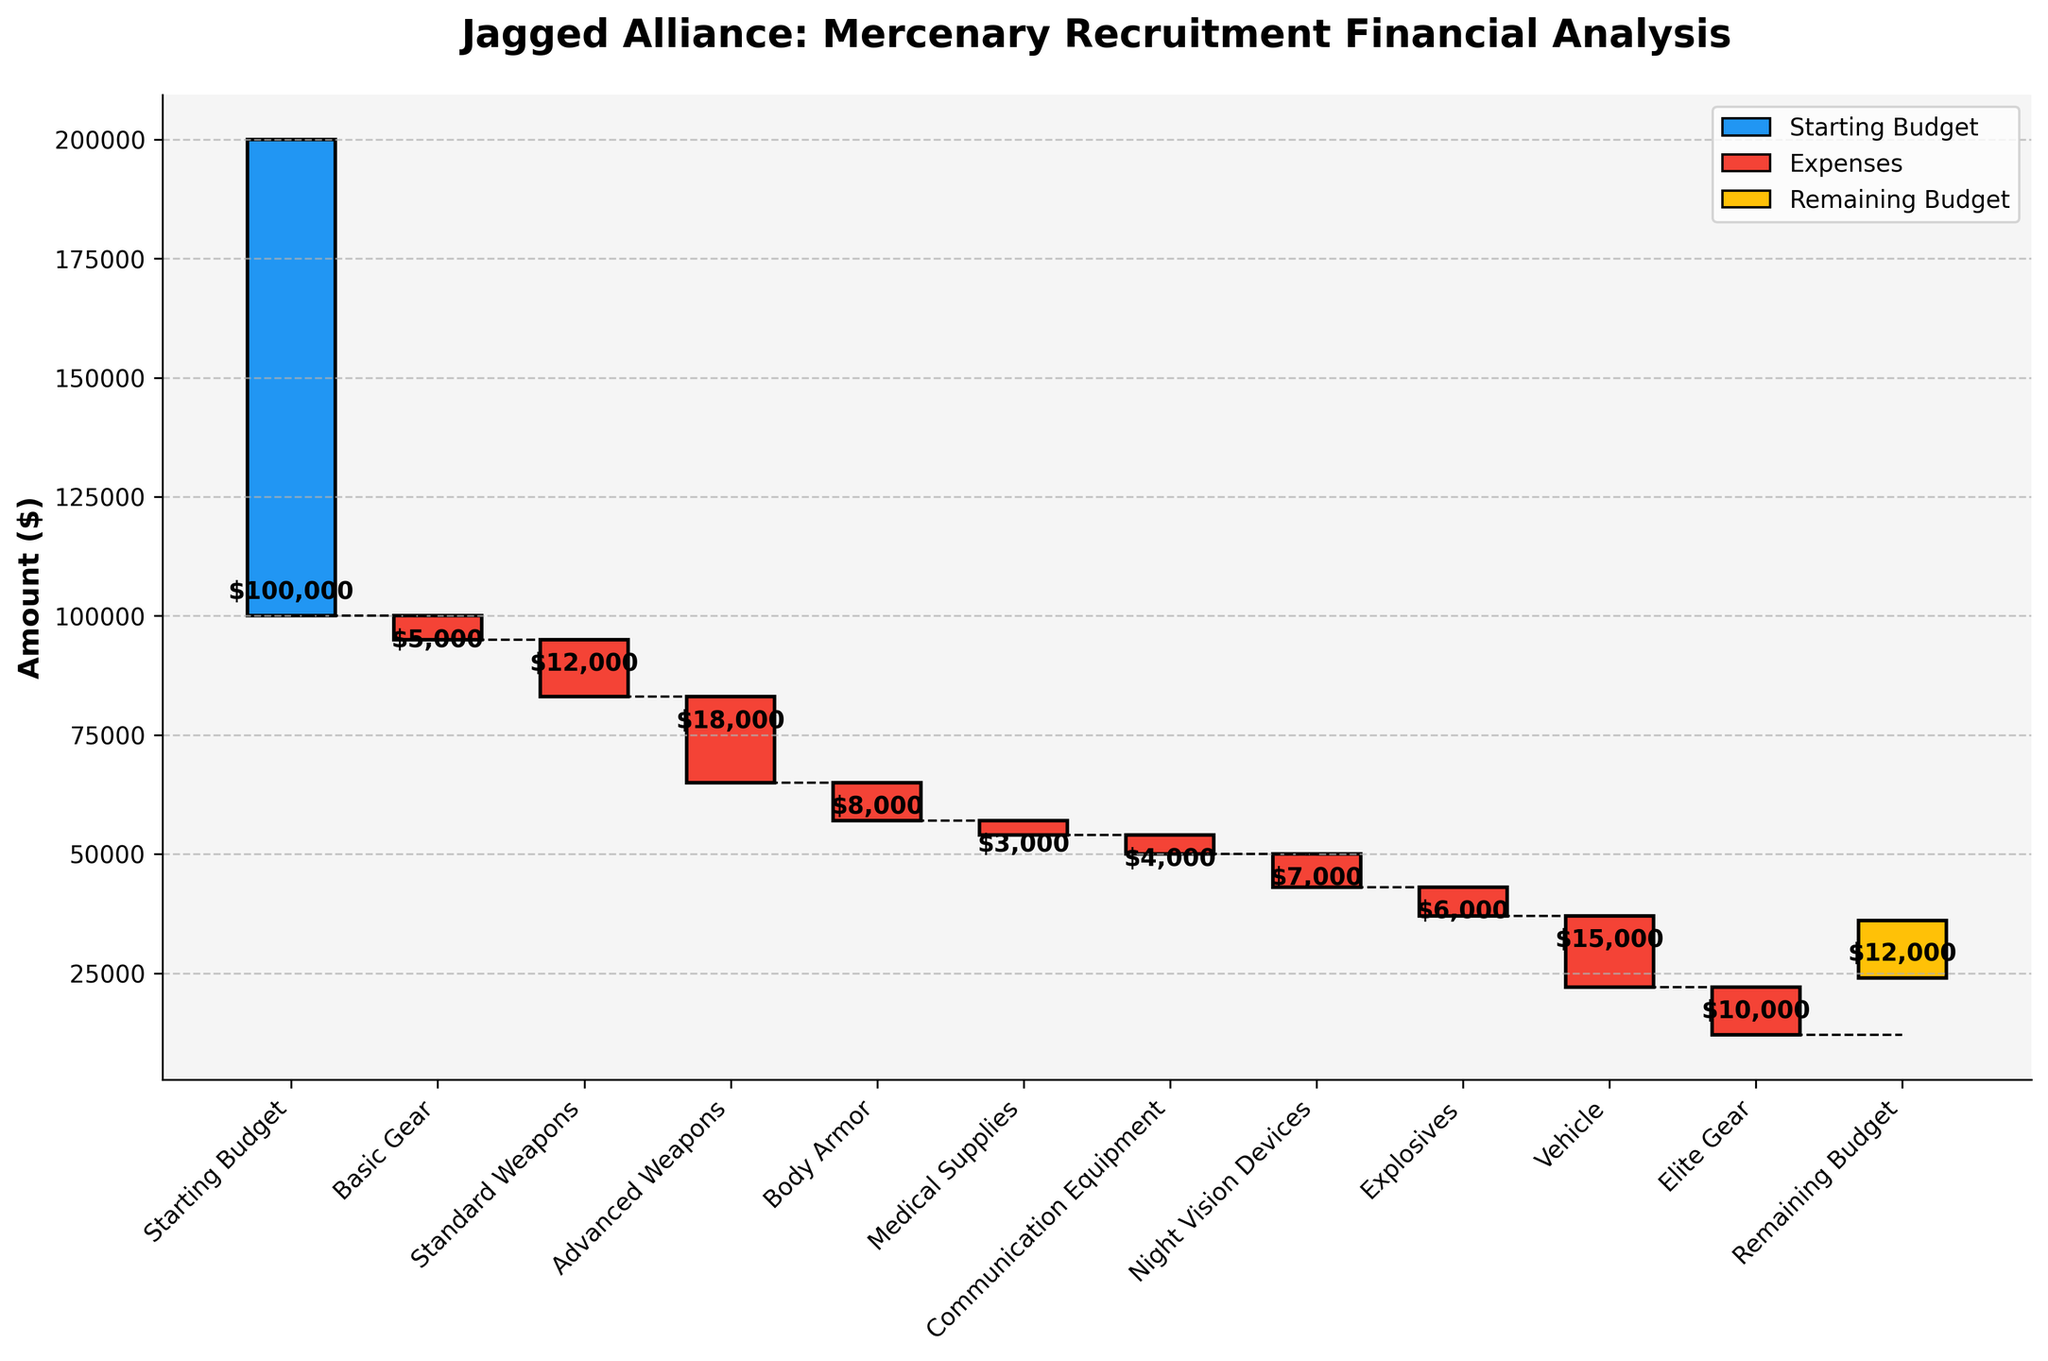What is the title of the plot? The title usually appears at the top of the plot and provides a general idea of what the plot is about. Here, the title is "Jagged Alliance: Mercenary Recruitment Financial Analysis".
Answer: Jagged Alliance: Mercenary Recruitment Financial Analysis What does the initial bar represent, and what is its value? The initial bar represents the starting point of the analysis and usually denotes the initial budget or funds available. In this plot, it represents the "Starting Budget" with a value of $100,000.
Answer: Starting Budget: $100,000 How much is spent on Basic Gear? To find this, look at the "Basic Gear" bar and note the value on its label. The "Basic Gear" expenditure is $5,000 less from the initial budget.
Answer: $5,000 What is the color used for the remainder budget, and what does it signify? The remainder budget uses a unique color to highlight it, helping to differentiate it from expenses and the starting budget. In this plot, it is represented in yellow (gold), signifying the Remaining Budget.
Answer: Yellow What category has the highest expense, and what is the value? To find the highest expense, compare the heights (or absolute values) of the negative bars. The largest deduction is in the "Vehicle" category, with a value of $15,000.
Answer: Vehicle: $15,000 What is the total amount spent on Advanced Weapons and Body Armor combined? To find the combined expense, sum the values indicated for "Advanced Weapons" and "Body Armor". Advanced Weapons cost $18,000, and Body Armor costs $8,000, making the total \(18,000 + 8,000 = 26,000\).
Answer: $26,000 How does the cost of standard weapons compare to the cost of night vision devices? Comparison involves looking at the values for both categories. Standard Weapons cost $12,000, while Night Vision Devices cost $7,000. Therefore, Standard Weapons are more expensive.
Answer: Standard Weapons are more expensive by $5,000 What would the remaining budget be if Elite Gear was not purchased? To determine this, add the cost of Elite Gear back to the remaining budget. The remaining budget is $12,000, and Elite Gear costs $10,000, so without purchasing Elite Gear, it would be $12,000 + $10,000 = $22,000.
Answer: $22,000 How many categories are listed before the remaining budget? Count the number of bars or categories that appear before the "Remaining Budget" label. There are 10 categories listed before the Remaining Budget.
Answer: 10 If Medical Supplies and Communication Equipment costs were nullified, what would the new remaining budget be? First, calculate the total freed up by nullifying Medical Supplies and Communication Equipment, which is \(3,000 + 4,000 = 7,000\). Then, add this to the current remaining budget: $12,000 + $7,000 = $19,000.
Answer: $19,000 